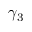Convert formula to latex. <formula><loc_0><loc_0><loc_500><loc_500>\gamma _ { 3 }</formula> 